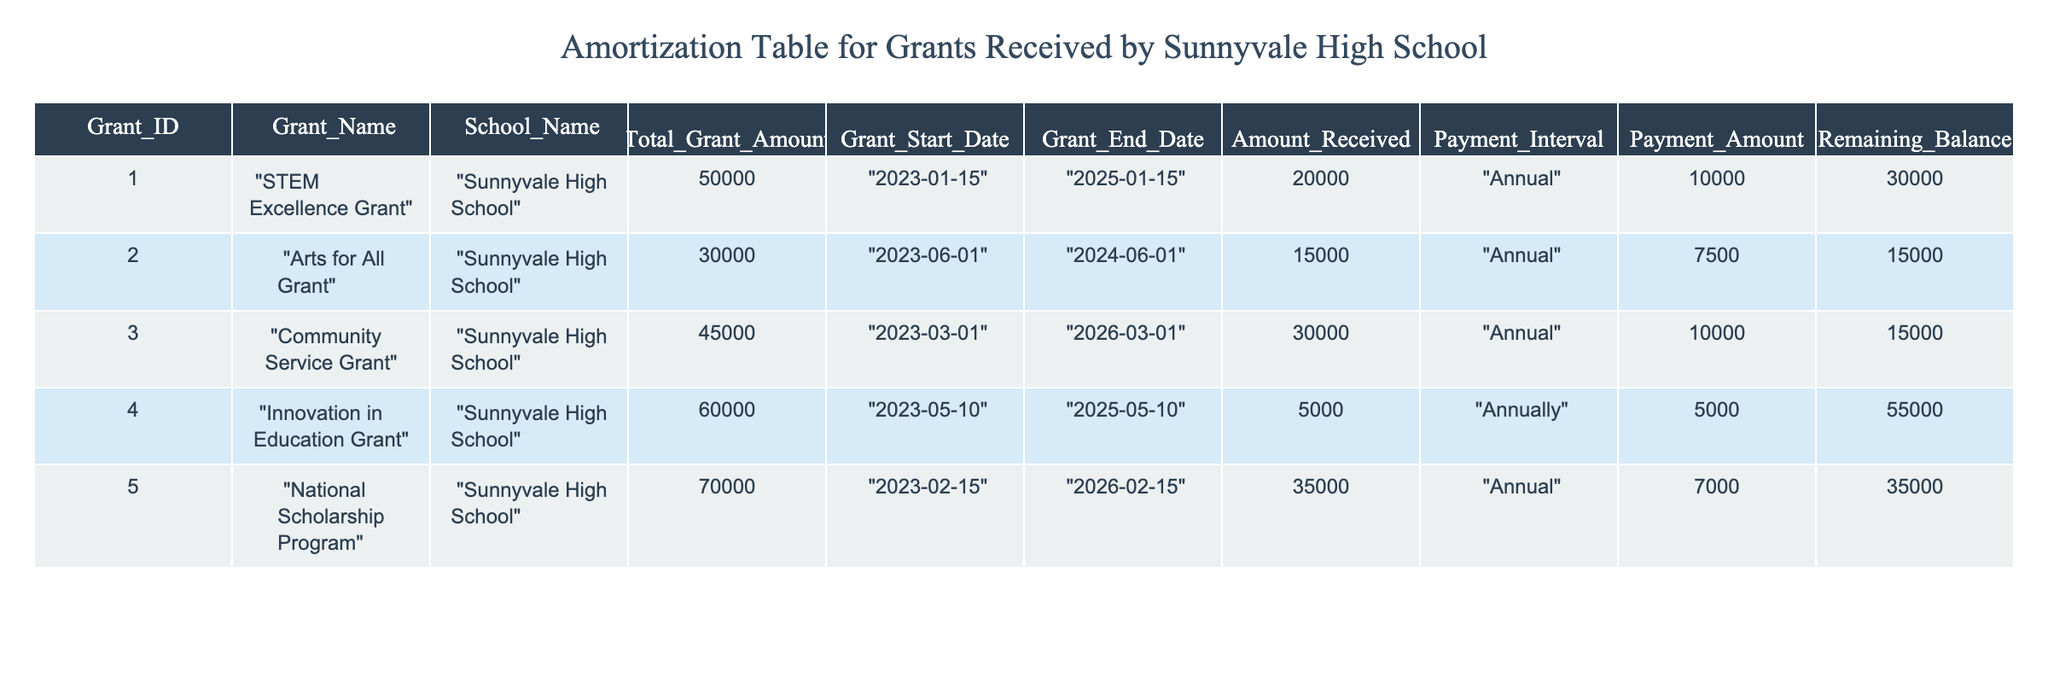What is the total grant amount for the "STEM Excellence Grant"? The table shows that the "STEM Excellence Grant" has a total grant amount listed as 50000.
Answer: 50000 How much grant money has been received for the "National Scholarship Program"? According to the table, the grant money received for the "National Scholarship Program" is 35000.
Answer: 35000 What is the remaining balance for all grants combined? To find the total remaining balance, we add the remaining balances of all grants: 30000 + 15000 + 15000 + 55000 + 35000 = 150000.
Answer: 150000 Which grant has the largest remaining balance? The "Innovation in Education Grant" has the largest remaining balance of 55000 compared to others, as evident in the "Remaining_Balance" column.
Answer: Innovation in Education Grant Is the total amount received for the "Arts for All Grant" more than the "Community Service Grant"? The amount received for the "Arts for All Grant" is 15000 while the "Community Service Grant" is 30000, meaning the "Arts for All Grant" received less. Thus, the statement is false.
Answer: No How much more was received for the "Community Service Grant" compared to the "Arts for All Grant"? The "Community Service Grant" received 30000 and the "Arts for All Grant" received 15000. The difference is 30000 - 15000 = 15000.
Answer: 15000 Which grant has the earliest start date? The "STEM Excellence Grant" starts on "2023-01-15," which is earlier than the start dates of the other grants.
Answer: STEM Excellence Grant If the grants are received annually, how many total payments remain for the "National Scholarship Program"? The "National Scholarship Program" has a remaining balance of 35000 and a payment amount of 7000. To find the number of payments remaining, we divide the remaining balance by the payment amount: 35000 / 7000 = 5.
Answer: 5 What is the average payment amount for the grants over all the grants listed? The payment amounts for the grants are 10000, 7500, 10000, 5000, and 7000. Adding these gives 40000, and dividing by the number of grants (5) gives an average of 40000 / 5 = 8000.
Answer: 8000 